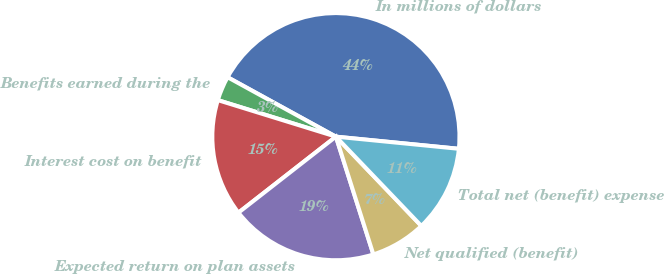Convert chart to OTSL. <chart><loc_0><loc_0><loc_500><loc_500><pie_chart><fcel>In millions of dollars<fcel>Benefits earned during the<fcel>Interest cost on benefit<fcel>Expected return on plan assets<fcel>Net qualified (benefit)<fcel>Total net (benefit) expense<nl><fcel>43.58%<fcel>3.21%<fcel>15.32%<fcel>19.36%<fcel>7.25%<fcel>11.28%<nl></chart> 